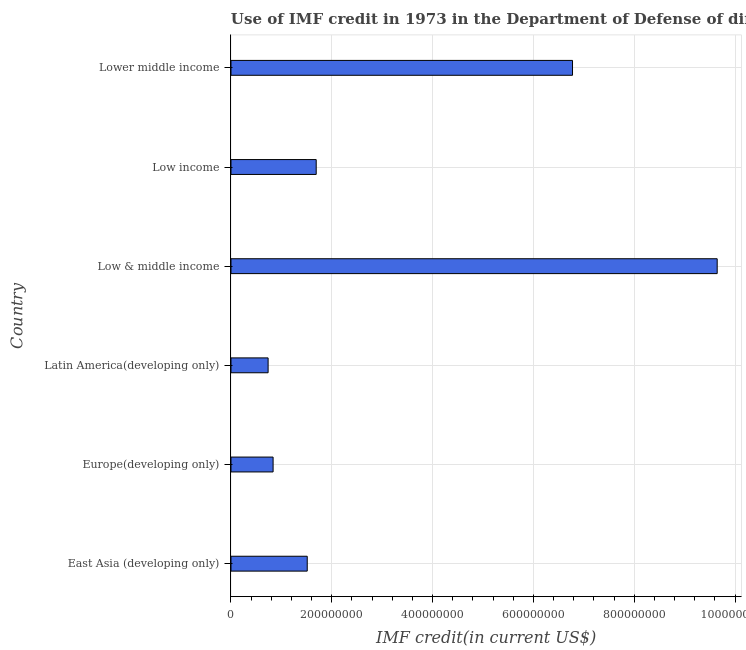Does the graph contain any zero values?
Your answer should be very brief. No. What is the title of the graph?
Your answer should be compact. Use of IMF credit in 1973 in the Department of Defense of different countries. What is the label or title of the X-axis?
Offer a very short reply. IMF credit(in current US$). What is the use of imf credit in dod in Europe(developing only)?
Provide a succinct answer. 8.35e+07. Across all countries, what is the maximum use of imf credit in dod?
Give a very brief answer. 9.64e+08. Across all countries, what is the minimum use of imf credit in dod?
Offer a terse response. 7.37e+07. In which country was the use of imf credit in dod minimum?
Provide a succinct answer. Latin America(developing only). What is the sum of the use of imf credit in dod?
Provide a short and direct response. 2.12e+09. What is the difference between the use of imf credit in dod in Europe(developing only) and Lower middle income?
Keep it short and to the point. -5.94e+08. What is the average use of imf credit in dod per country?
Make the answer very short. 3.53e+08. What is the median use of imf credit in dod?
Keep it short and to the point. 1.60e+08. In how many countries, is the use of imf credit in dod greater than 520000000 US$?
Your response must be concise. 2. What is the ratio of the use of imf credit in dod in East Asia (developing only) to that in Low & middle income?
Make the answer very short. 0.16. Is the use of imf credit in dod in East Asia (developing only) less than that in Low income?
Ensure brevity in your answer.  Yes. Is the difference between the use of imf credit in dod in East Asia (developing only) and Latin America(developing only) greater than the difference between any two countries?
Offer a very short reply. No. What is the difference between the highest and the second highest use of imf credit in dod?
Offer a terse response. 2.87e+08. What is the difference between the highest and the lowest use of imf credit in dod?
Your answer should be very brief. 8.91e+08. In how many countries, is the use of imf credit in dod greater than the average use of imf credit in dod taken over all countries?
Your answer should be compact. 2. Are all the bars in the graph horizontal?
Offer a terse response. Yes. What is the difference between two consecutive major ticks on the X-axis?
Ensure brevity in your answer.  2.00e+08. Are the values on the major ticks of X-axis written in scientific E-notation?
Your answer should be compact. No. What is the IMF credit(in current US$) in East Asia (developing only)?
Offer a very short reply. 1.51e+08. What is the IMF credit(in current US$) of Europe(developing only)?
Offer a very short reply. 8.35e+07. What is the IMF credit(in current US$) in Latin America(developing only)?
Your answer should be compact. 7.37e+07. What is the IMF credit(in current US$) in Low & middle income?
Ensure brevity in your answer.  9.64e+08. What is the IMF credit(in current US$) of Low income?
Offer a terse response. 1.69e+08. What is the IMF credit(in current US$) in Lower middle income?
Provide a short and direct response. 6.77e+08. What is the difference between the IMF credit(in current US$) in East Asia (developing only) and Europe(developing only)?
Provide a short and direct response. 6.77e+07. What is the difference between the IMF credit(in current US$) in East Asia (developing only) and Latin America(developing only)?
Give a very brief answer. 7.76e+07. What is the difference between the IMF credit(in current US$) in East Asia (developing only) and Low & middle income?
Your response must be concise. -8.13e+08. What is the difference between the IMF credit(in current US$) in East Asia (developing only) and Low income?
Provide a succinct answer. -1.78e+07. What is the difference between the IMF credit(in current US$) in East Asia (developing only) and Lower middle income?
Make the answer very short. -5.26e+08. What is the difference between the IMF credit(in current US$) in Europe(developing only) and Latin America(developing only)?
Your response must be concise. 9.89e+06. What is the difference between the IMF credit(in current US$) in Europe(developing only) and Low & middle income?
Offer a terse response. -8.81e+08. What is the difference between the IMF credit(in current US$) in Europe(developing only) and Low income?
Ensure brevity in your answer.  -8.55e+07. What is the difference between the IMF credit(in current US$) in Europe(developing only) and Lower middle income?
Keep it short and to the point. -5.94e+08. What is the difference between the IMF credit(in current US$) in Latin America(developing only) and Low & middle income?
Your answer should be very brief. -8.91e+08. What is the difference between the IMF credit(in current US$) in Latin America(developing only) and Low income?
Your response must be concise. -9.54e+07. What is the difference between the IMF credit(in current US$) in Latin America(developing only) and Lower middle income?
Ensure brevity in your answer.  -6.04e+08. What is the difference between the IMF credit(in current US$) in Low & middle income and Low income?
Keep it short and to the point. 7.95e+08. What is the difference between the IMF credit(in current US$) in Low & middle income and Lower middle income?
Make the answer very short. 2.87e+08. What is the difference between the IMF credit(in current US$) in Low income and Lower middle income?
Your answer should be very brief. -5.08e+08. What is the ratio of the IMF credit(in current US$) in East Asia (developing only) to that in Europe(developing only)?
Offer a terse response. 1.81. What is the ratio of the IMF credit(in current US$) in East Asia (developing only) to that in Latin America(developing only)?
Provide a short and direct response. 2.05. What is the ratio of the IMF credit(in current US$) in East Asia (developing only) to that in Low & middle income?
Your response must be concise. 0.16. What is the ratio of the IMF credit(in current US$) in East Asia (developing only) to that in Low income?
Your response must be concise. 0.9. What is the ratio of the IMF credit(in current US$) in East Asia (developing only) to that in Lower middle income?
Offer a terse response. 0.22. What is the ratio of the IMF credit(in current US$) in Europe(developing only) to that in Latin America(developing only)?
Your answer should be very brief. 1.13. What is the ratio of the IMF credit(in current US$) in Europe(developing only) to that in Low & middle income?
Provide a succinct answer. 0.09. What is the ratio of the IMF credit(in current US$) in Europe(developing only) to that in Low income?
Your response must be concise. 0.49. What is the ratio of the IMF credit(in current US$) in Europe(developing only) to that in Lower middle income?
Keep it short and to the point. 0.12. What is the ratio of the IMF credit(in current US$) in Latin America(developing only) to that in Low & middle income?
Your answer should be very brief. 0.08. What is the ratio of the IMF credit(in current US$) in Latin America(developing only) to that in Low income?
Offer a terse response. 0.44. What is the ratio of the IMF credit(in current US$) in Latin America(developing only) to that in Lower middle income?
Offer a very short reply. 0.11. What is the ratio of the IMF credit(in current US$) in Low & middle income to that in Low income?
Your answer should be very brief. 5.71. What is the ratio of the IMF credit(in current US$) in Low & middle income to that in Lower middle income?
Keep it short and to the point. 1.42. 